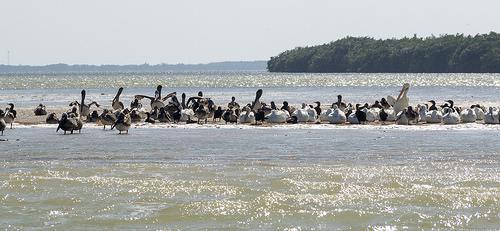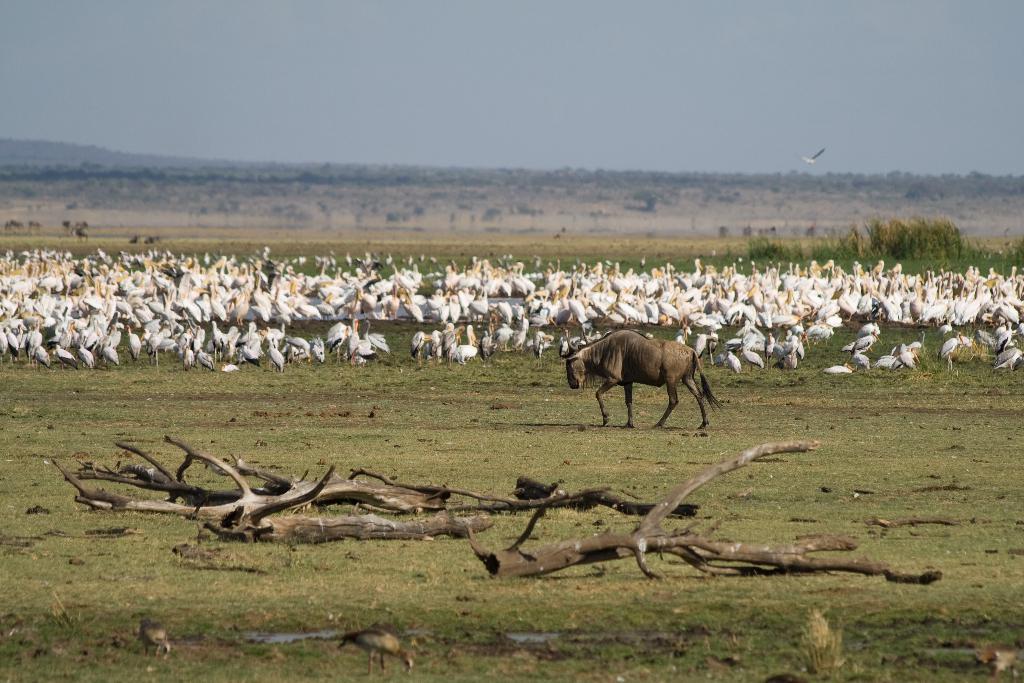The first image is the image on the left, the second image is the image on the right. Analyze the images presented: Is the assertion "The image on the right contains an animal that is not a bird." valid? Answer yes or no. Yes. The first image is the image on the left, the second image is the image on the right. Examine the images to the left and right. Is the description "There is at least one picture where water is not visible." accurate? Answer yes or no. Yes. 